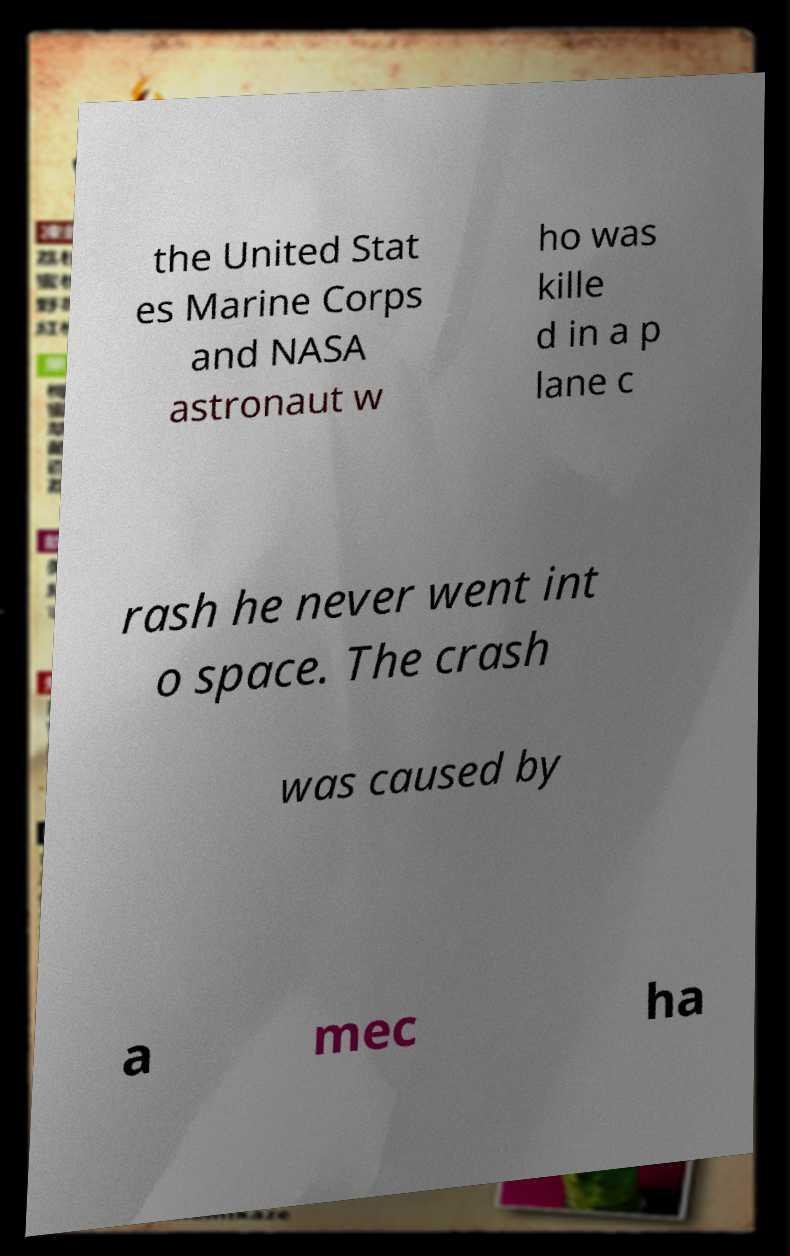Could you assist in decoding the text presented in this image and type it out clearly? the United Stat es Marine Corps and NASA astronaut w ho was kille d in a p lane c rash he never went int o space. The crash was caused by a mec ha 